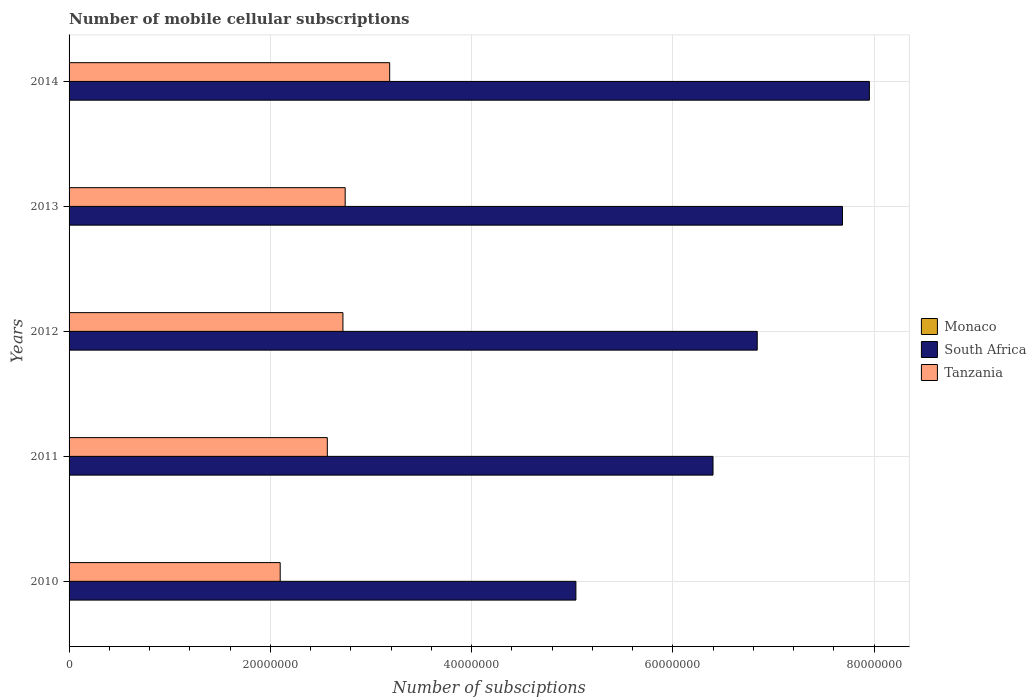How many groups of bars are there?
Ensure brevity in your answer.  5. Are the number of bars per tick equal to the number of legend labels?
Ensure brevity in your answer.  Yes. What is the label of the 1st group of bars from the top?
Your response must be concise. 2014. In how many cases, is the number of bars for a given year not equal to the number of legend labels?
Your answer should be very brief. 0. What is the number of mobile cellular subscriptions in Monaco in 2014?
Offer a terse response. 3.37e+04. Across all years, what is the maximum number of mobile cellular subscriptions in South Africa?
Offer a terse response. 7.95e+07. Across all years, what is the minimum number of mobile cellular subscriptions in South Africa?
Your answer should be compact. 5.04e+07. In which year was the number of mobile cellular subscriptions in South Africa maximum?
Give a very brief answer. 2014. In which year was the number of mobile cellular subscriptions in Monaco minimum?
Give a very brief answer. 2010. What is the total number of mobile cellular subscriptions in Monaco in the graph?
Your answer should be very brief. 1.58e+05. What is the difference between the number of mobile cellular subscriptions in South Africa in 2012 and that in 2013?
Make the answer very short. -8.47e+06. What is the difference between the number of mobile cellular subscriptions in Tanzania in 2014 and the number of mobile cellular subscriptions in South Africa in 2013?
Offer a very short reply. -4.50e+07. What is the average number of mobile cellular subscriptions in Tanzania per year?
Keep it short and to the point. 2.66e+07. In the year 2011, what is the difference between the number of mobile cellular subscriptions in Tanzania and number of mobile cellular subscriptions in South Africa?
Make the answer very short. -3.83e+07. In how many years, is the number of mobile cellular subscriptions in Monaco greater than 12000000 ?
Your response must be concise. 0. What is the ratio of the number of mobile cellular subscriptions in Tanzania in 2013 to that in 2014?
Provide a succinct answer. 0.86. Is the difference between the number of mobile cellular subscriptions in Tanzania in 2011 and 2012 greater than the difference between the number of mobile cellular subscriptions in South Africa in 2011 and 2012?
Your answer should be compact. Yes. What is the difference between the highest and the second highest number of mobile cellular subscriptions in Monaco?
Ensure brevity in your answer.  1789. What is the difference between the highest and the lowest number of mobile cellular subscriptions in Monaco?
Your answer should be very brief. 1.20e+04. In how many years, is the number of mobile cellular subscriptions in South Africa greater than the average number of mobile cellular subscriptions in South Africa taken over all years?
Make the answer very short. 3. What does the 3rd bar from the top in 2010 represents?
Your response must be concise. Monaco. What does the 3rd bar from the bottom in 2010 represents?
Provide a short and direct response. Tanzania. Is it the case that in every year, the sum of the number of mobile cellular subscriptions in South Africa and number of mobile cellular subscriptions in Monaco is greater than the number of mobile cellular subscriptions in Tanzania?
Keep it short and to the point. Yes. How many bars are there?
Provide a succinct answer. 15. How many years are there in the graph?
Make the answer very short. 5. Does the graph contain any zero values?
Provide a succinct answer. No. Where does the legend appear in the graph?
Give a very brief answer. Center right. How many legend labels are there?
Provide a succinct answer. 3. What is the title of the graph?
Give a very brief answer. Number of mobile cellular subscriptions. Does "Bermuda" appear as one of the legend labels in the graph?
Provide a succinct answer. No. What is the label or title of the X-axis?
Provide a succinct answer. Number of subsciptions. What is the label or title of the Y-axis?
Provide a short and direct response. Years. What is the Number of subsciptions in Monaco in 2010?
Provide a short and direct response. 2.34e+04. What is the Number of subsciptions in South Africa in 2010?
Provide a short and direct response. 5.04e+07. What is the Number of subsciptions of Tanzania in 2010?
Your answer should be very brief. 2.10e+07. What is the Number of subsciptions in Monaco in 2011?
Keep it short and to the point. 3.18e+04. What is the Number of subsciptions in South Africa in 2011?
Give a very brief answer. 6.40e+07. What is the Number of subsciptions of Tanzania in 2011?
Ensure brevity in your answer.  2.57e+07. What is the Number of subsciptions of Monaco in 2012?
Provide a short and direct response. 3.32e+04. What is the Number of subsciptions of South Africa in 2012?
Keep it short and to the point. 6.84e+07. What is the Number of subsciptions in Tanzania in 2012?
Provide a succinct answer. 2.72e+07. What is the Number of subsciptions of Monaco in 2013?
Provide a succinct answer. 3.55e+04. What is the Number of subsciptions in South Africa in 2013?
Make the answer very short. 7.69e+07. What is the Number of subsciptions of Tanzania in 2013?
Provide a succinct answer. 2.74e+07. What is the Number of subsciptions of Monaco in 2014?
Your answer should be compact. 3.37e+04. What is the Number of subsciptions in South Africa in 2014?
Provide a short and direct response. 7.95e+07. What is the Number of subsciptions of Tanzania in 2014?
Ensure brevity in your answer.  3.19e+07. Across all years, what is the maximum Number of subsciptions in Monaco?
Give a very brief answer. 3.55e+04. Across all years, what is the maximum Number of subsciptions of South Africa?
Offer a terse response. 7.95e+07. Across all years, what is the maximum Number of subsciptions in Tanzania?
Your answer should be very brief. 3.19e+07. Across all years, what is the minimum Number of subsciptions in Monaco?
Your response must be concise. 2.34e+04. Across all years, what is the minimum Number of subsciptions in South Africa?
Your answer should be compact. 5.04e+07. Across all years, what is the minimum Number of subsciptions of Tanzania?
Ensure brevity in your answer.  2.10e+07. What is the total Number of subsciptions in Monaco in the graph?
Ensure brevity in your answer.  1.58e+05. What is the total Number of subsciptions in South Africa in the graph?
Offer a very short reply. 3.39e+08. What is the total Number of subsciptions in Tanzania in the graph?
Your response must be concise. 1.33e+08. What is the difference between the Number of subsciptions in Monaco in 2010 and that in 2011?
Ensure brevity in your answer.  -8375. What is the difference between the Number of subsciptions of South Africa in 2010 and that in 2011?
Your answer should be very brief. -1.36e+07. What is the difference between the Number of subsciptions in Tanzania in 2010 and that in 2011?
Ensure brevity in your answer.  -4.68e+06. What is the difference between the Number of subsciptions in Monaco in 2010 and that in 2012?
Provide a short and direct response. -9781. What is the difference between the Number of subsciptions in South Africa in 2010 and that in 2012?
Provide a succinct answer. -1.80e+07. What is the difference between the Number of subsciptions in Tanzania in 2010 and that in 2012?
Offer a terse response. -6.24e+06. What is the difference between the Number of subsciptions of Monaco in 2010 and that in 2013?
Make the answer very short. -1.20e+04. What is the difference between the Number of subsciptions of South Africa in 2010 and that in 2013?
Offer a terse response. -2.65e+07. What is the difference between the Number of subsciptions of Tanzania in 2010 and that in 2013?
Give a very brief answer. -6.46e+06. What is the difference between the Number of subsciptions in Monaco in 2010 and that in 2014?
Provide a succinct answer. -1.03e+04. What is the difference between the Number of subsciptions in South Africa in 2010 and that in 2014?
Your answer should be very brief. -2.92e+07. What is the difference between the Number of subsciptions in Tanzania in 2010 and that in 2014?
Provide a succinct answer. -1.09e+07. What is the difference between the Number of subsciptions in Monaco in 2011 and that in 2012?
Provide a short and direct response. -1406. What is the difference between the Number of subsciptions in South Africa in 2011 and that in 2012?
Offer a terse response. -4.39e+06. What is the difference between the Number of subsciptions of Tanzania in 2011 and that in 2012?
Your answer should be very brief. -1.55e+06. What is the difference between the Number of subsciptions in Monaco in 2011 and that in 2013?
Your answer should be very brief. -3675. What is the difference between the Number of subsciptions of South Africa in 2011 and that in 2013?
Offer a terse response. -1.29e+07. What is the difference between the Number of subsciptions of Tanzania in 2011 and that in 2013?
Offer a terse response. -1.78e+06. What is the difference between the Number of subsciptions in Monaco in 2011 and that in 2014?
Provide a short and direct response. -1886. What is the difference between the Number of subsciptions of South Africa in 2011 and that in 2014?
Offer a terse response. -1.55e+07. What is the difference between the Number of subsciptions of Tanzania in 2011 and that in 2014?
Your answer should be very brief. -6.20e+06. What is the difference between the Number of subsciptions of Monaco in 2012 and that in 2013?
Provide a succinct answer. -2269. What is the difference between the Number of subsciptions in South Africa in 2012 and that in 2013?
Your answer should be very brief. -8.47e+06. What is the difference between the Number of subsciptions in Tanzania in 2012 and that in 2013?
Your response must be concise. -2.24e+05. What is the difference between the Number of subsciptions in Monaco in 2012 and that in 2014?
Provide a succinct answer. -480. What is the difference between the Number of subsciptions in South Africa in 2012 and that in 2014?
Ensure brevity in your answer.  -1.11e+07. What is the difference between the Number of subsciptions in Tanzania in 2012 and that in 2014?
Your response must be concise. -4.64e+06. What is the difference between the Number of subsciptions in Monaco in 2013 and that in 2014?
Make the answer very short. 1789. What is the difference between the Number of subsciptions in South Africa in 2013 and that in 2014?
Offer a very short reply. -2.67e+06. What is the difference between the Number of subsciptions in Tanzania in 2013 and that in 2014?
Provide a short and direct response. -4.42e+06. What is the difference between the Number of subsciptions of Monaco in 2010 and the Number of subsciptions of South Africa in 2011?
Provide a succinct answer. -6.40e+07. What is the difference between the Number of subsciptions of Monaco in 2010 and the Number of subsciptions of Tanzania in 2011?
Offer a very short reply. -2.56e+07. What is the difference between the Number of subsciptions of South Africa in 2010 and the Number of subsciptions of Tanzania in 2011?
Ensure brevity in your answer.  2.47e+07. What is the difference between the Number of subsciptions in Monaco in 2010 and the Number of subsciptions in South Africa in 2012?
Your response must be concise. -6.84e+07. What is the difference between the Number of subsciptions in Monaco in 2010 and the Number of subsciptions in Tanzania in 2012?
Keep it short and to the point. -2.72e+07. What is the difference between the Number of subsciptions of South Africa in 2010 and the Number of subsciptions of Tanzania in 2012?
Provide a short and direct response. 2.32e+07. What is the difference between the Number of subsciptions of Monaco in 2010 and the Number of subsciptions of South Africa in 2013?
Make the answer very short. -7.68e+07. What is the difference between the Number of subsciptions in Monaco in 2010 and the Number of subsciptions in Tanzania in 2013?
Provide a succinct answer. -2.74e+07. What is the difference between the Number of subsciptions in South Africa in 2010 and the Number of subsciptions in Tanzania in 2013?
Your answer should be very brief. 2.29e+07. What is the difference between the Number of subsciptions of Monaco in 2010 and the Number of subsciptions of South Africa in 2014?
Offer a very short reply. -7.95e+07. What is the difference between the Number of subsciptions in Monaco in 2010 and the Number of subsciptions in Tanzania in 2014?
Your response must be concise. -3.18e+07. What is the difference between the Number of subsciptions in South Africa in 2010 and the Number of subsciptions in Tanzania in 2014?
Offer a very short reply. 1.85e+07. What is the difference between the Number of subsciptions in Monaco in 2011 and the Number of subsciptions in South Africa in 2012?
Provide a succinct answer. -6.84e+07. What is the difference between the Number of subsciptions in Monaco in 2011 and the Number of subsciptions in Tanzania in 2012?
Ensure brevity in your answer.  -2.72e+07. What is the difference between the Number of subsciptions of South Africa in 2011 and the Number of subsciptions of Tanzania in 2012?
Offer a terse response. 3.68e+07. What is the difference between the Number of subsciptions of Monaco in 2011 and the Number of subsciptions of South Africa in 2013?
Your answer should be compact. -7.68e+07. What is the difference between the Number of subsciptions in Monaco in 2011 and the Number of subsciptions in Tanzania in 2013?
Your answer should be very brief. -2.74e+07. What is the difference between the Number of subsciptions in South Africa in 2011 and the Number of subsciptions in Tanzania in 2013?
Give a very brief answer. 3.66e+07. What is the difference between the Number of subsciptions of Monaco in 2011 and the Number of subsciptions of South Africa in 2014?
Keep it short and to the point. -7.95e+07. What is the difference between the Number of subsciptions in Monaco in 2011 and the Number of subsciptions in Tanzania in 2014?
Your response must be concise. -3.18e+07. What is the difference between the Number of subsciptions in South Africa in 2011 and the Number of subsciptions in Tanzania in 2014?
Provide a short and direct response. 3.21e+07. What is the difference between the Number of subsciptions of Monaco in 2012 and the Number of subsciptions of South Africa in 2013?
Offer a very short reply. -7.68e+07. What is the difference between the Number of subsciptions of Monaco in 2012 and the Number of subsciptions of Tanzania in 2013?
Make the answer very short. -2.74e+07. What is the difference between the Number of subsciptions in South Africa in 2012 and the Number of subsciptions in Tanzania in 2013?
Ensure brevity in your answer.  4.10e+07. What is the difference between the Number of subsciptions of Monaco in 2012 and the Number of subsciptions of South Africa in 2014?
Offer a very short reply. -7.95e+07. What is the difference between the Number of subsciptions of Monaco in 2012 and the Number of subsciptions of Tanzania in 2014?
Keep it short and to the point. -3.18e+07. What is the difference between the Number of subsciptions of South Africa in 2012 and the Number of subsciptions of Tanzania in 2014?
Provide a succinct answer. 3.65e+07. What is the difference between the Number of subsciptions in Monaco in 2013 and the Number of subsciptions in South Africa in 2014?
Provide a short and direct response. -7.95e+07. What is the difference between the Number of subsciptions of Monaco in 2013 and the Number of subsciptions of Tanzania in 2014?
Keep it short and to the point. -3.18e+07. What is the difference between the Number of subsciptions in South Africa in 2013 and the Number of subsciptions in Tanzania in 2014?
Your answer should be compact. 4.50e+07. What is the average Number of subsciptions in Monaco per year?
Provide a short and direct response. 3.15e+04. What is the average Number of subsciptions in South Africa per year?
Provide a succinct answer. 6.78e+07. What is the average Number of subsciptions in Tanzania per year?
Your answer should be compact. 2.66e+07. In the year 2010, what is the difference between the Number of subsciptions in Monaco and Number of subsciptions in South Africa?
Keep it short and to the point. -5.03e+07. In the year 2010, what is the difference between the Number of subsciptions in Monaco and Number of subsciptions in Tanzania?
Ensure brevity in your answer.  -2.10e+07. In the year 2010, what is the difference between the Number of subsciptions of South Africa and Number of subsciptions of Tanzania?
Make the answer very short. 2.94e+07. In the year 2011, what is the difference between the Number of subsciptions of Monaco and Number of subsciptions of South Africa?
Keep it short and to the point. -6.40e+07. In the year 2011, what is the difference between the Number of subsciptions in Monaco and Number of subsciptions in Tanzania?
Provide a short and direct response. -2.56e+07. In the year 2011, what is the difference between the Number of subsciptions in South Africa and Number of subsciptions in Tanzania?
Give a very brief answer. 3.83e+07. In the year 2012, what is the difference between the Number of subsciptions of Monaco and Number of subsciptions of South Africa?
Your answer should be very brief. -6.84e+07. In the year 2012, what is the difference between the Number of subsciptions in Monaco and Number of subsciptions in Tanzania?
Make the answer very short. -2.72e+07. In the year 2012, what is the difference between the Number of subsciptions in South Africa and Number of subsciptions in Tanzania?
Keep it short and to the point. 4.12e+07. In the year 2013, what is the difference between the Number of subsciptions in Monaco and Number of subsciptions in South Africa?
Keep it short and to the point. -7.68e+07. In the year 2013, what is the difference between the Number of subsciptions in Monaco and Number of subsciptions in Tanzania?
Make the answer very short. -2.74e+07. In the year 2013, what is the difference between the Number of subsciptions of South Africa and Number of subsciptions of Tanzania?
Ensure brevity in your answer.  4.94e+07. In the year 2014, what is the difference between the Number of subsciptions in Monaco and Number of subsciptions in South Africa?
Your answer should be very brief. -7.95e+07. In the year 2014, what is the difference between the Number of subsciptions in Monaco and Number of subsciptions in Tanzania?
Offer a very short reply. -3.18e+07. In the year 2014, what is the difference between the Number of subsciptions in South Africa and Number of subsciptions in Tanzania?
Offer a very short reply. 4.77e+07. What is the ratio of the Number of subsciptions in Monaco in 2010 to that in 2011?
Give a very brief answer. 0.74. What is the ratio of the Number of subsciptions of South Africa in 2010 to that in 2011?
Your answer should be compact. 0.79. What is the ratio of the Number of subsciptions of Tanzania in 2010 to that in 2011?
Your response must be concise. 0.82. What is the ratio of the Number of subsciptions in Monaco in 2010 to that in 2012?
Make the answer very short. 0.71. What is the ratio of the Number of subsciptions of South Africa in 2010 to that in 2012?
Your answer should be very brief. 0.74. What is the ratio of the Number of subsciptions in Tanzania in 2010 to that in 2012?
Make the answer very short. 0.77. What is the ratio of the Number of subsciptions in Monaco in 2010 to that in 2013?
Provide a short and direct response. 0.66. What is the ratio of the Number of subsciptions in South Africa in 2010 to that in 2013?
Your response must be concise. 0.66. What is the ratio of the Number of subsciptions in Tanzania in 2010 to that in 2013?
Offer a very short reply. 0.76. What is the ratio of the Number of subsciptions of Monaco in 2010 to that in 2014?
Your answer should be very brief. 0.7. What is the ratio of the Number of subsciptions of South Africa in 2010 to that in 2014?
Your response must be concise. 0.63. What is the ratio of the Number of subsciptions of Tanzania in 2010 to that in 2014?
Keep it short and to the point. 0.66. What is the ratio of the Number of subsciptions in Monaco in 2011 to that in 2012?
Your response must be concise. 0.96. What is the ratio of the Number of subsciptions in South Africa in 2011 to that in 2012?
Your response must be concise. 0.94. What is the ratio of the Number of subsciptions of Tanzania in 2011 to that in 2012?
Give a very brief answer. 0.94. What is the ratio of the Number of subsciptions in Monaco in 2011 to that in 2013?
Your answer should be compact. 0.9. What is the ratio of the Number of subsciptions of South Africa in 2011 to that in 2013?
Provide a short and direct response. 0.83. What is the ratio of the Number of subsciptions of Tanzania in 2011 to that in 2013?
Your response must be concise. 0.94. What is the ratio of the Number of subsciptions in Monaco in 2011 to that in 2014?
Your response must be concise. 0.94. What is the ratio of the Number of subsciptions of South Africa in 2011 to that in 2014?
Make the answer very short. 0.8. What is the ratio of the Number of subsciptions in Tanzania in 2011 to that in 2014?
Your answer should be very brief. 0.81. What is the ratio of the Number of subsciptions in Monaco in 2012 to that in 2013?
Offer a very short reply. 0.94. What is the ratio of the Number of subsciptions in South Africa in 2012 to that in 2013?
Ensure brevity in your answer.  0.89. What is the ratio of the Number of subsciptions in Monaco in 2012 to that in 2014?
Provide a short and direct response. 0.99. What is the ratio of the Number of subsciptions of South Africa in 2012 to that in 2014?
Ensure brevity in your answer.  0.86. What is the ratio of the Number of subsciptions of Tanzania in 2012 to that in 2014?
Give a very brief answer. 0.85. What is the ratio of the Number of subsciptions in Monaco in 2013 to that in 2014?
Your response must be concise. 1.05. What is the ratio of the Number of subsciptions of South Africa in 2013 to that in 2014?
Make the answer very short. 0.97. What is the ratio of the Number of subsciptions of Tanzania in 2013 to that in 2014?
Your answer should be compact. 0.86. What is the difference between the highest and the second highest Number of subsciptions of Monaco?
Make the answer very short. 1789. What is the difference between the highest and the second highest Number of subsciptions in South Africa?
Ensure brevity in your answer.  2.67e+06. What is the difference between the highest and the second highest Number of subsciptions of Tanzania?
Keep it short and to the point. 4.42e+06. What is the difference between the highest and the lowest Number of subsciptions in Monaco?
Provide a short and direct response. 1.20e+04. What is the difference between the highest and the lowest Number of subsciptions of South Africa?
Keep it short and to the point. 2.92e+07. What is the difference between the highest and the lowest Number of subsciptions of Tanzania?
Offer a very short reply. 1.09e+07. 